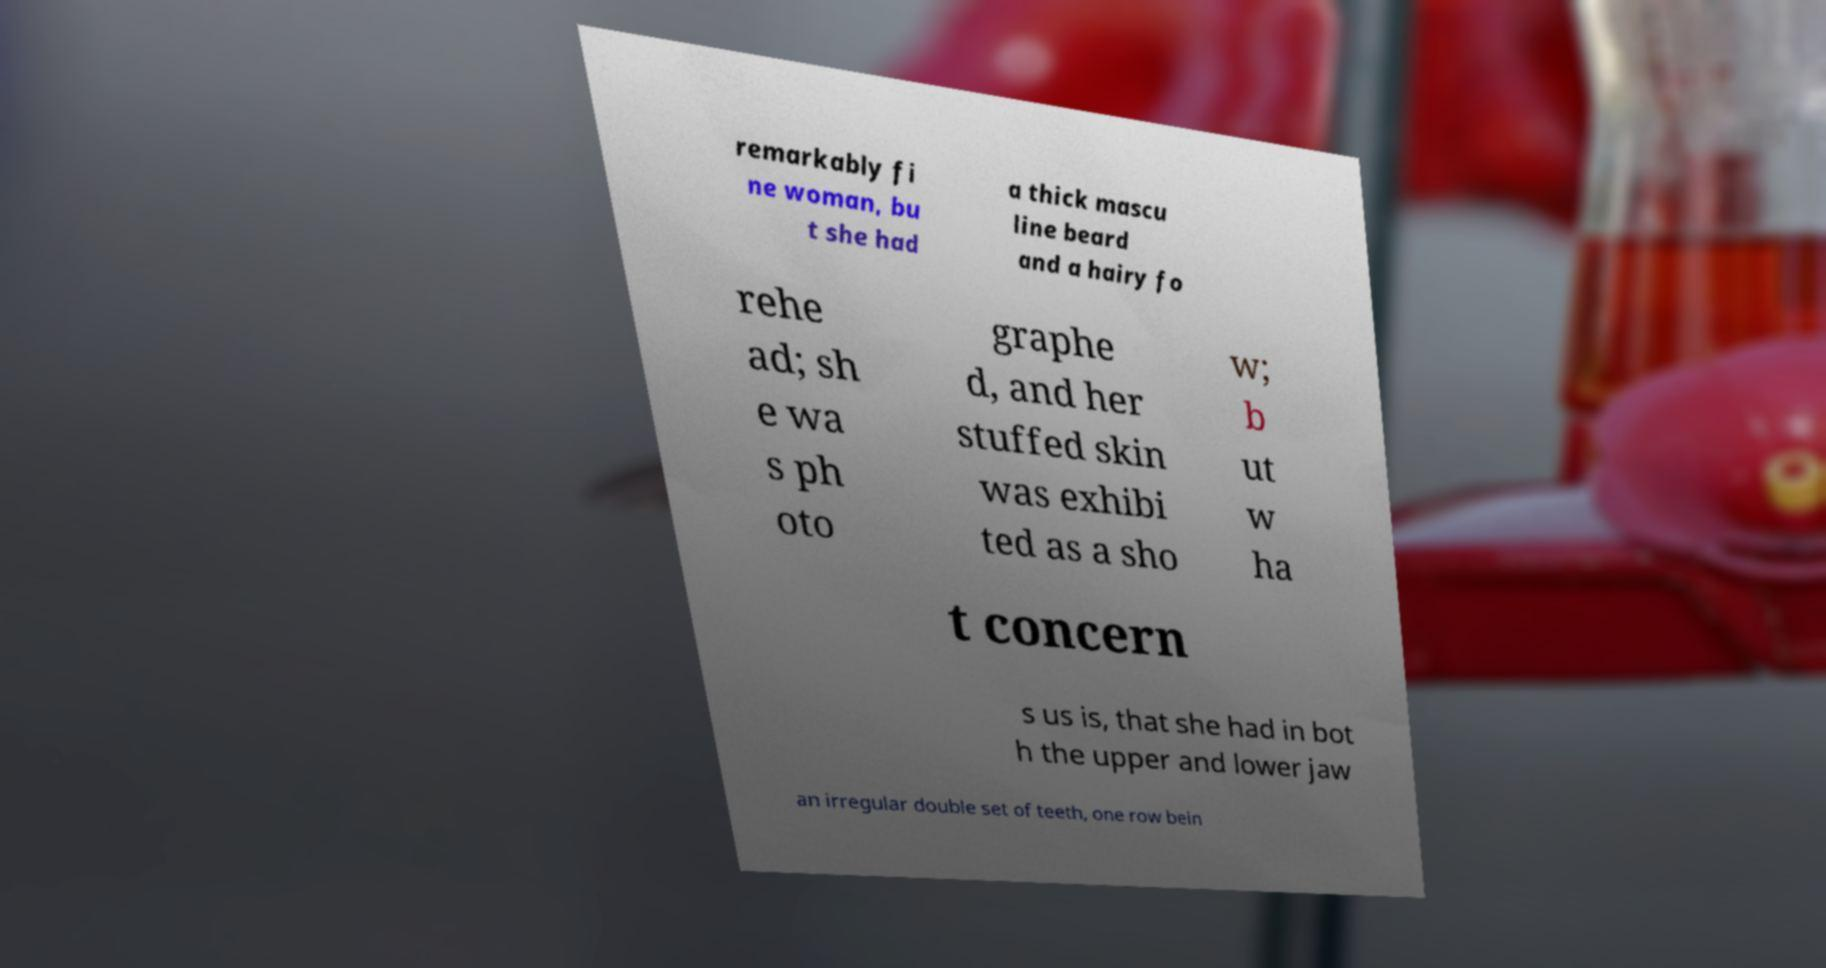I need the written content from this picture converted into text. Can you do that? remarkably fi ne woman, bu t she had a thick mascu line beard and a hairy fo rehe ad; sh e wa s ph oto graphe d, and her stuffed skin was exhibi ted as a sho w; b ut w ha t concern s us is, that she had in bot h the upper and lower jaw an irregular double set of teeth, one row bein 